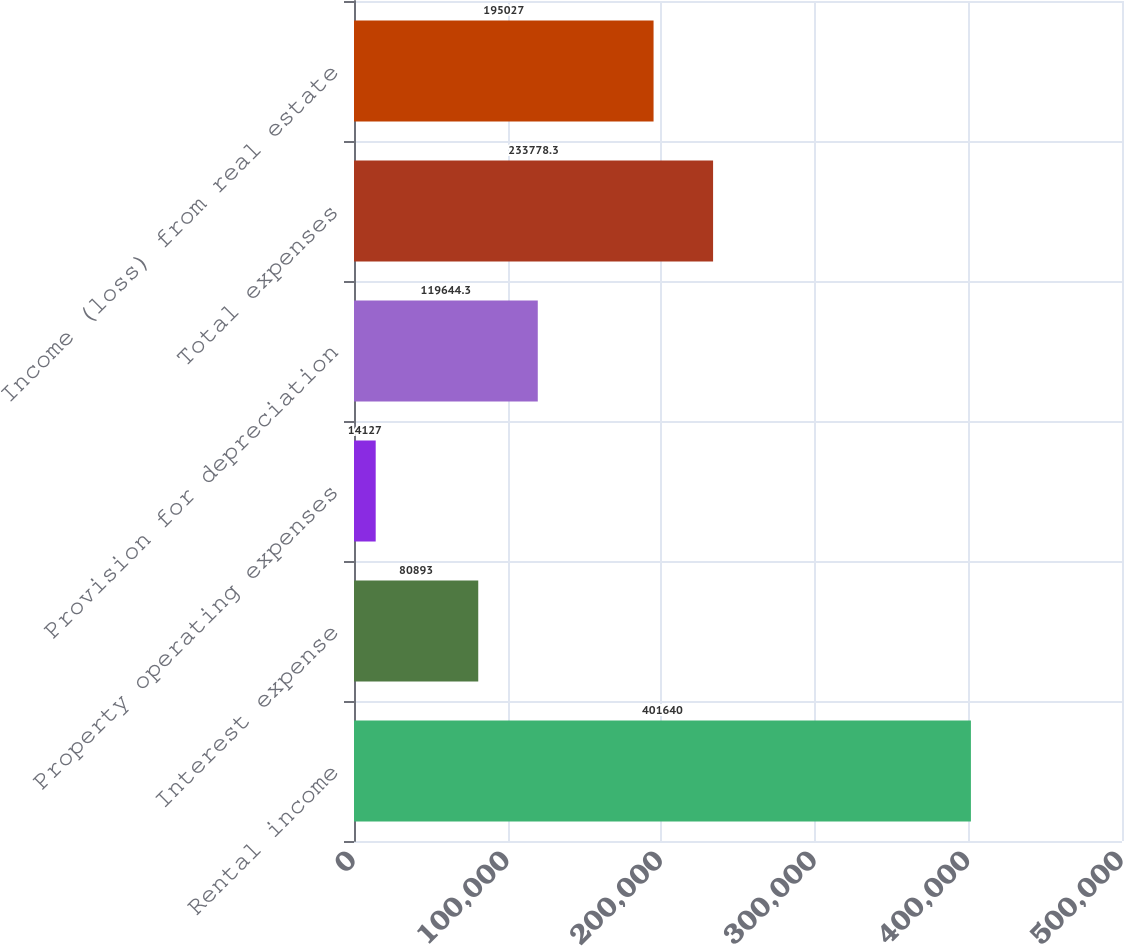Convert chart. <chart><loc_0><loc_0><loc_500><loc_500><bar_chart><fcel>Rental income<fcel>Interest expense<fcel>Property operating expenses<fcel>Provision for depreciation<fcel>Total expenses<fcel>Income (loss) from real estate<nl><fcel>401640<fcel>80893<fcel>14127<fcel>119644<fcel>233778<fcel>195027<nl></chart> 